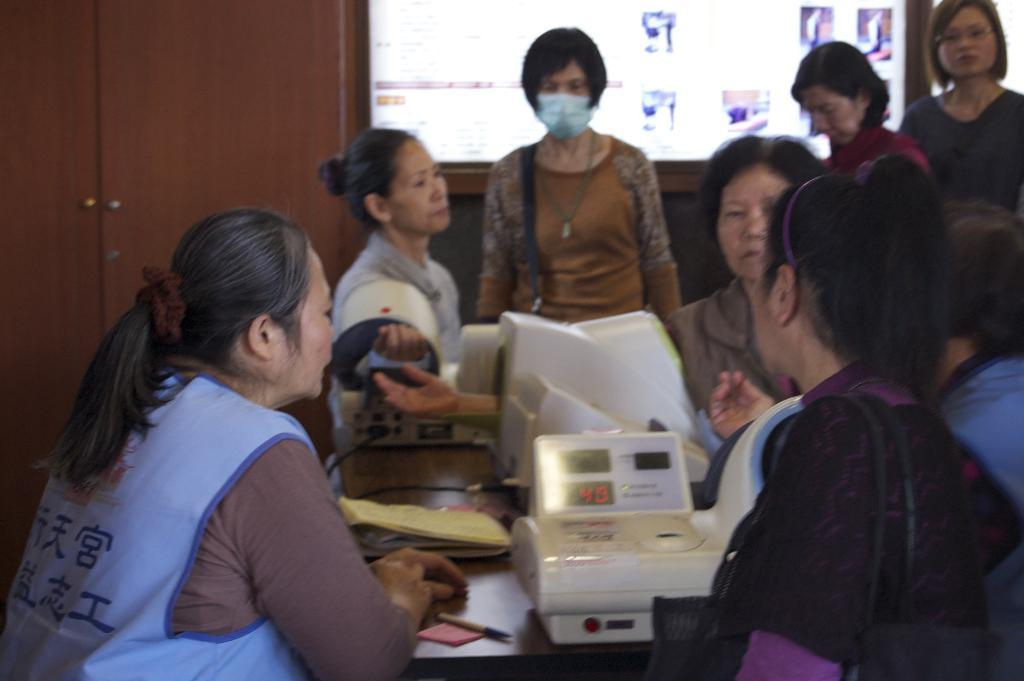What objects can be seen in the image related to work or productivity? There are machines, a book, papers, and a pen on the table in the image. What is the purpose of the pen on the table? The pen on the table might be used for writing or taking notes. What can be seen in the background of the image? There is a group of persons standing, a screen, and a cupboard in the background. What might the screen in the background be used for? The screen in the background might be used for displaying information or presentations. What type of key is used to unlock the spot on the glass in the image? There is no key, spot, or glass present in the image. 